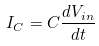Convert formula to latex. <formula><loc_0><loc_0><loc_500><loc_500>I _ { C } = C \frac { d V _ { i n } } { d t }</formula> 